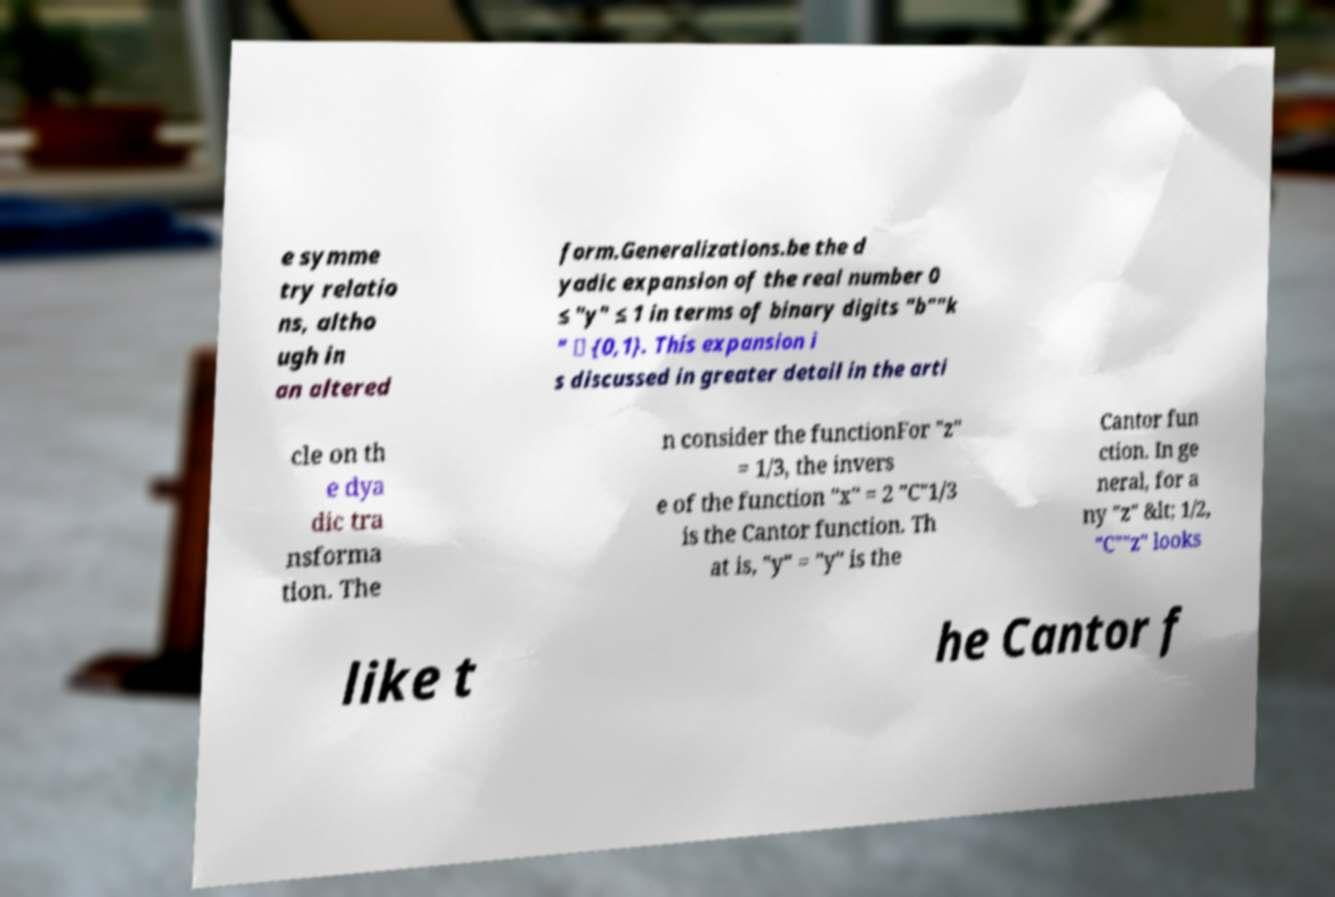What messages or text are displayed in this image? I need them in a readable, typed format. e symme try relatio ns, altho ugh in an altered form.Generalizations.be the d yadic expansion of the real number 0 ≤ "y" ≤ 1 in terms of binary digits "b""k " ∈ {0,1}. This expansion i s discussed in greater detail in the arti cle on th e dya dic tra nsforma tion. The n consider the functionFor "z" = 1/3, the invers e of the function "x" = 2 "C"1/3 is the Cantor function. Th at is, "y" = "y" is the Cantor fun ction. In ge neral, for a ny "z" &lt; 1/2, "C""z" looks like t he Cantor f 